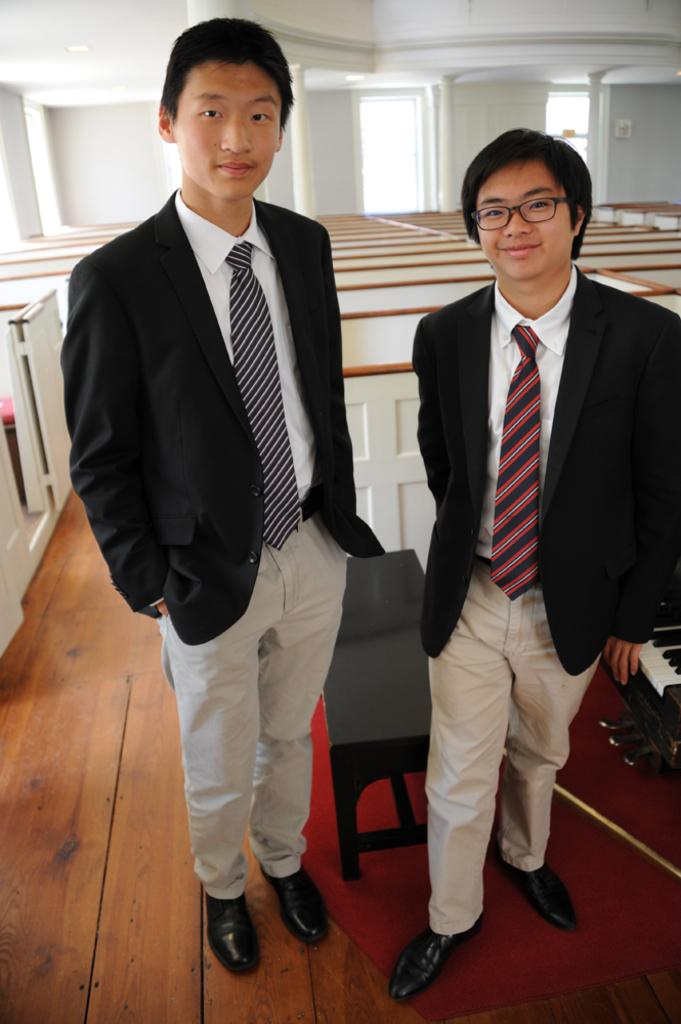How many men are present in the image? There are two men in the image. What are the men wearing in the image? Both men are wearing blazers and ties. Where are the men standing in the image? The men are standing on the floor. What can be seen in the background of the image? There are tables, a wall, and pillars in the background of the image. Can you see any toothbrushes in the image? There are no toothbrushes present in the image. How many cows are visible in the image? There are no cows visible in the image. 